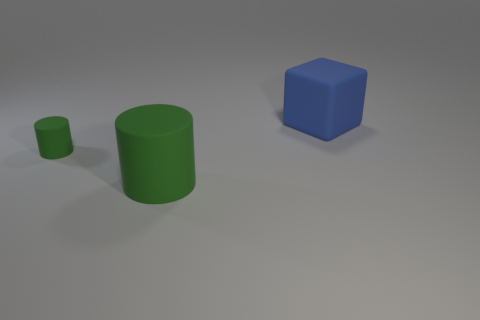Add 2 small rubber objects. How many objects exist? 5 Subtract all blocks. How many objects are left? 2 Add 3 big blue matte blocks. How many big blue matte blocks are left? 4 Add 3 small green things. How many small green things exist? 4 Subtract 0 yellow cylinders. How many objects are left? 3 Subtract all cyan cylinders. Subtract all brown cubes. How many cylinders are left? 2 Subtract all tiny green rubber things. Subtract all blue matte objects. How many objects are left? 1 